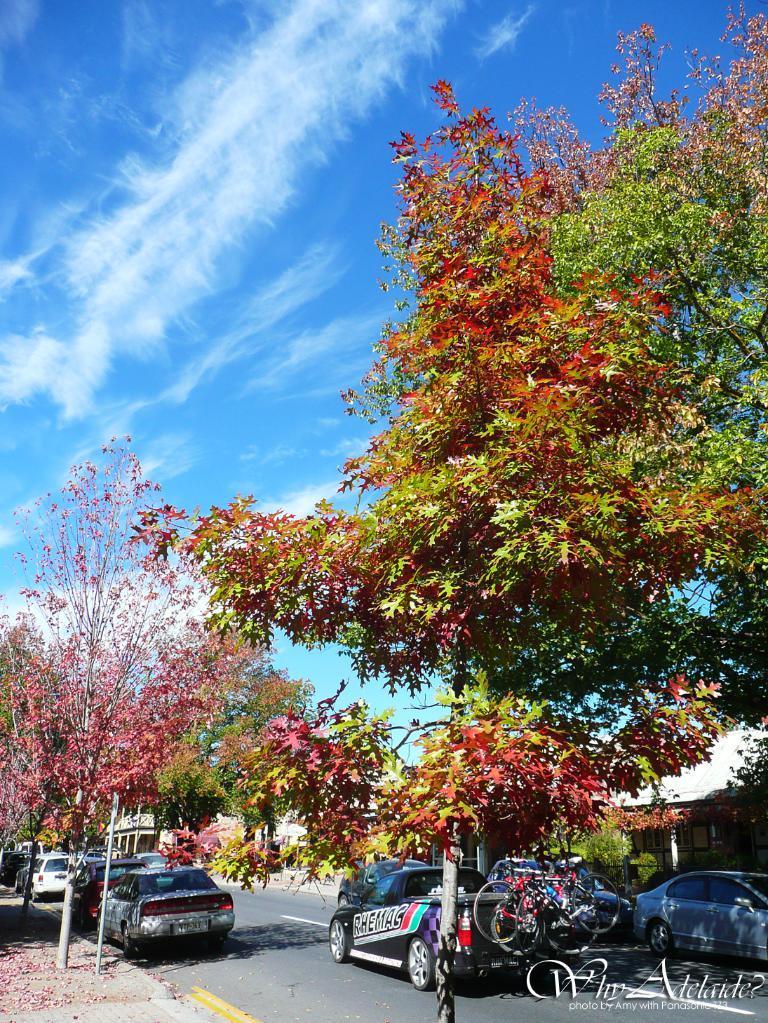Could you give a brief overview of what you see in this image? This picture is clicked outside the city. Here, we see many cars moving on the road. On either side of the road, there are trees and on the right side, we see a white building. At the top of the picture, we see the sky, which is blue in color. 